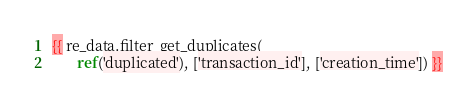Convert code to text. <code><loc_0><loc_0><loc_500><loc_500><_SQL_> {{ re_data.filter_get_duplicates(
        ref('duplicated'), ['transaction_id'], ['creation_time']) }}

</code> 